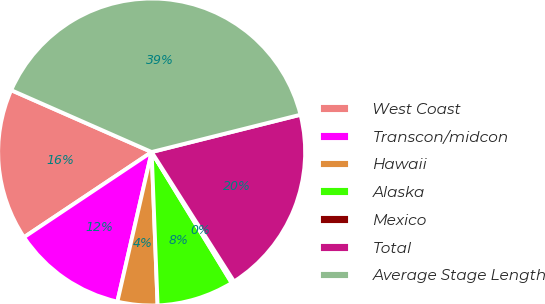Convert chart to OTSL. <chart><loc_0><loc_0><loc_500><loc_500><pie_chart><fcel>West Coast<fcel>Transcon/midcon<fcel>Hawaii<fcel>Alaska<fcel>Mexico<fcel>Total<fcel>Average Stage Length<nl><fcel>15.97%<fcel>12.05%<fcel>4.2%<fcel>8.12%<fcel>0.28%<fcel>19.89%<fcel>39.49%<nl></chart> 